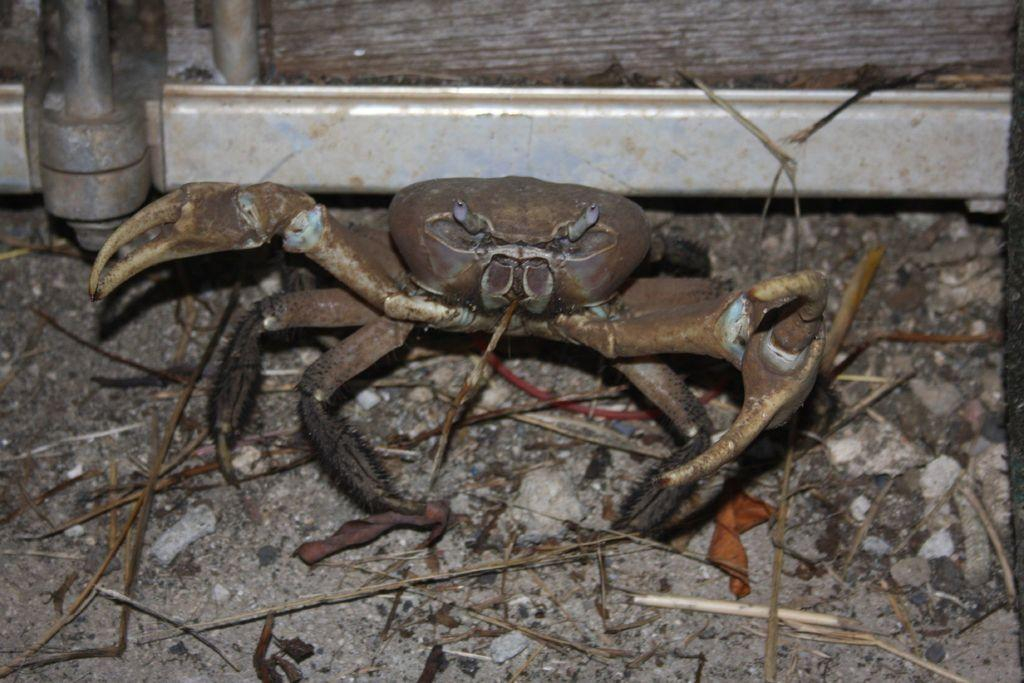What animal can be seen on the ground in the image? There is a crab on the ground in the image. What type of natural objects are present on the ground? There are dried sticks and dried leaves on the ground. What can be seen in the background of the image? There is a wall visible in the background. What type of feather can be seen on the crab in the image? There are no feathers present on the crab in the image. Is there a camp set up in the background of the image? There is no camp visible in the background of the image. 